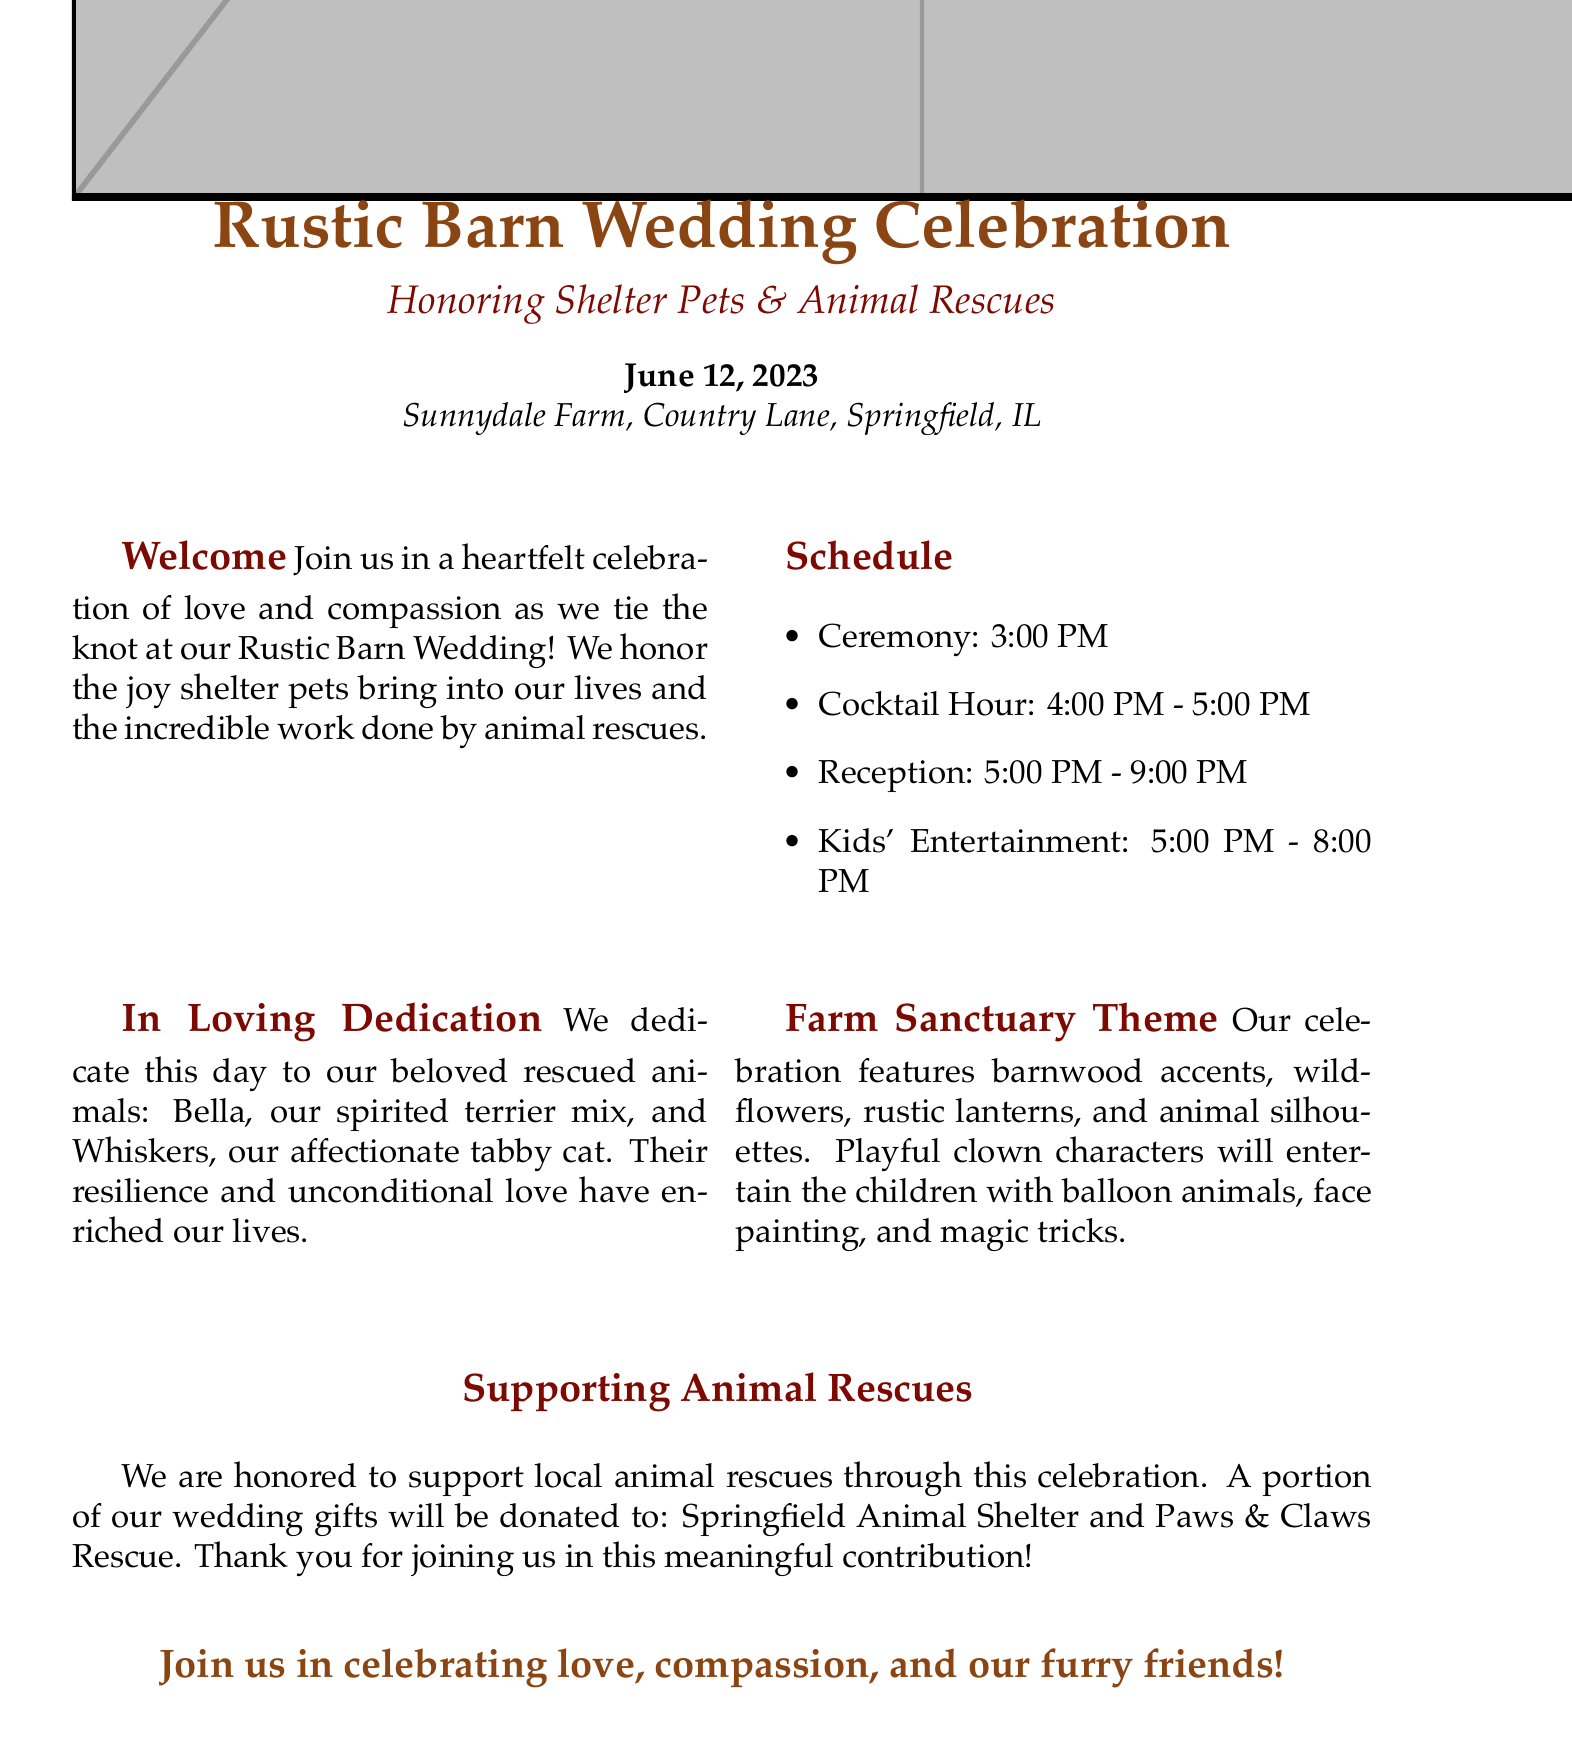What is the date of the wedding? The wedding date is specifically mentioned in the document.
Answer: June 12, 2023 Where is the wedding taking place? The location of the wedding is provided in the invitation.
Answer: Sunnydale Farm, Country Lane, Springfield, IL What time does the ceremony begin? The start time of the ceremony is clearly stated in the schedule section.
Answer: 3:00 PM Who are the couple's rescued animals? The dedication section lists the names of the couple's rescued animals.
Answer: Bella and Whiskers What organization will receive donations from wedding gifts? The document mentions the organization that will benefit from the couple’s contributions.
Answer: Springfield Animal Shelter What kind of entertainment is provided for kids? The invitation specifies the type of activities scheduled for children.
Answer: Playful clown characters What colors are used in the design motifs? The document describes the design colors used in the wedding theme.
Answer: Rustic brown and barn red How long is the cocktail hour? The schedule indicates the duration of the cocktail hour.
Answer: 1 hour What theme is emphasized in the wedding celebration? The theme of the wedding is highlighted at the beginning of the document.
Answer: Farm Sanctuary Theme 